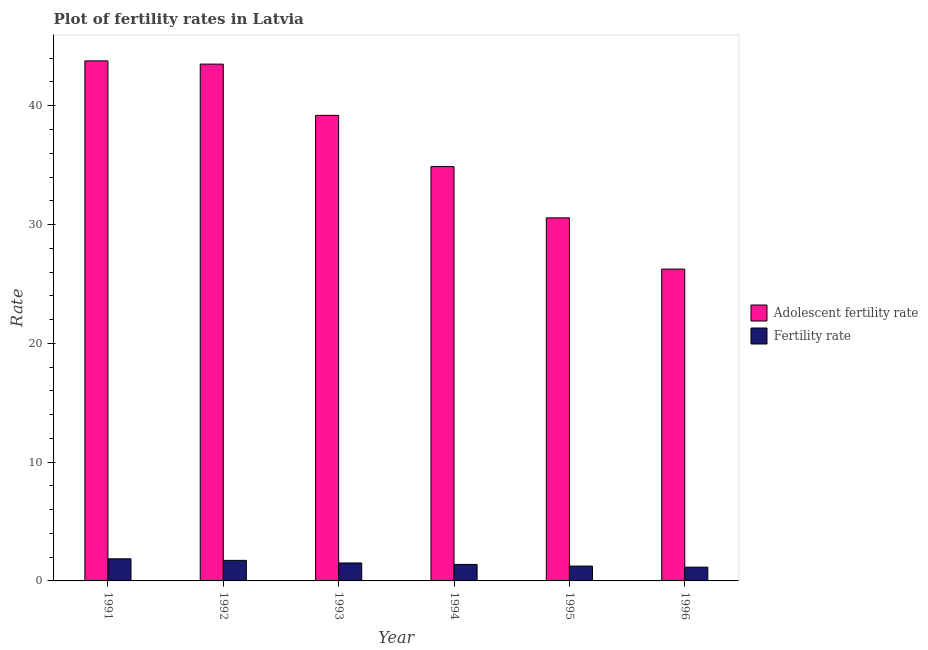How many different coloured bars are there?
Your response must be concise. 2. How many groups of bars are there?
Offer a terse response. 6. Are the number of bars on each tick of the X-axis equal?
Keep it short and to the point. Yes. How many bars are there on the 4th tick from the right?
Your response must be concise. 2. What is the label of the 3rd group of bars from the left?
Your response must be concise. 1993. In how many cases, is the number of bars for a given year not equal to the number of legend labels?
Provide a short and direct response. 0. What is the fertility rate in 1992?
Keep it short and to the point. 1.73. Across all years, what is the maximum adolescent fertility rate?
Give a very brief answer. 43.78. Across all years, what is the minimum adolescent fertility rate?
Offer a terse response. 26.25. In which year was the fertility rate minimum?
Keep it short and to the point. 1996. What is the total fertility rate in the graph?
Give a very brief answer. 8.9. What is the difference between the fertility rate in 1991 and that in 1994?
Keep it short and to the point. 0.47. What is the difference between the fertility rate in 1996 and the adolescent fertility rate in 1991?
Offer a very short reply. -0.7. What is the average adolescent fertility rate per year?
Keep it short and to the point. 36.36. In how many years, is the adolescent fertility rate greater than 14?
Ensure brevity in your answer.  6. What is the ratio of the adolescent fertility rate in 1991 to that in 1992?
Make the answer very short. 1.01. What is the difference between the highest and the second highest fertility rate?
Offer a very short reply. 0.13. What is the difference between the highest and the lowest adolescent fertility rate?
Offer a very short reply. 17.53. In how many years, is the fertility rate greater than the average fertility rate taken over all years?
Keep it short and to the point. 3. What does the 1st bar from the left in 1992 represents?
Offer a very short reply. Adolescent fertility rate. What does the 1st bar from the right in 1991 represents?
Keep it short and to the point. Fertility rate. How many years are there in the graph?
Give a very brief answer. 6. What is the difference between two consecutive major ticks on the Y-axis?
Your answer should be compact. 10. Are the values on the major ticks of Y-axis written in scientific E-notation?
Provide a succinct answer. No. Does the graph contain any zero values?
Provide a short and direct response. No. Where does the legend appear in the graph?
Offer a very short reply. Center right. How many legend labels are there?
Make the answer very short. 2. What is the title of the graph?
Make the answer very short. Plot of fertility rates in Latvia. What is the label or title of the X-axis?
Offer a terse response. Year. What is the label or title of the Y-axis?
Your answer should be very brief. Rate. What is the Rate in Adolescent fertility rate in 1991?
Give a very brief answer. 43.78. What is the Rate of Fertility rate in 1991?
Make the answer very short. 1.86. What is the Rate of Adolescent fertility rate in 1992?
Your answer should be compact. 43.51. What is the Rate in Fertility rate in 1992?
Your answer should be very brief. 1.73. What is the Rate of Adolescent fertility rate in 1993?
Offer a terse response. 39.19. What is the Rate of Fertility rate in 1993?
Provide a short and direct response. 1.51. What is the Rate in Adolescent fertility rate in 1994?
Provide a succinct answer. 34.88. What is the Rate in Fertility rate in 1994?
Provide a succinct answer. 1.39. What is the Rate in Adolescent fertility rate in 1995?
Offer a very short reply. 30.56. What is the Rate in Adolescent fertility rate in 1996?
Provide a succinct answer. 26.25. What is the Rate in Fertility rate in 1996?
Your response must be concise. 1.16. Across all years, what is the maximum Rate of Adolescent fertility rate?
Make the answer very short. 43.78. Across all years, what is the maximum Rate of Fertility rate?
Provide a succinct answer. 1.86. Across all years, what is the minimum Rate in Adolescent fertility rate?
Your answer should be compact. 26.25. Across all years, what is the minimum Rate of Fertility rate?
Provide a succinct answer. 1.16. What is the total Rate in Adolescent fertility rate in the graph?
Offer a terse response. 218.16. What is the total Rate in Fertility rate in the graph?
Give a very brief answer. 8.9. What is the difference between the Rate of Adolescent fertility rate in 1991 and that in 1992?
Ensure brevity in your answer.  0.27. What is the difference between the Rate of Fertility rate in 1991 and that in 1992?
Keep it short and to the point. 0.13. What is the difference between the Rate in Adolescent fertility rate in 1991 and that in 1993?
Provide a short and direct response. 4.59. What is the difference between the Rate in Adolescent fertility rate in 1991 and that in 1994?
Your answer should be compact. 8.9. What is the difference between the Rate in Fertility rate in 1991 and that in 1994?
Your response must be concise. 0.47. What is the difference between the Rate in Adolescent fertility rate in 1991 and that in 1995?
Your answer should be very brief. 13.21. What is the difference between the Rate of Fertility rate in 1991 and that in 1995?
Your answer should be compact. 0.61. What is the difference between the Rate of Adolescent fertility rate in 1991 and that in 1996?
Your response must be concise. 17.53. What is the difference between the Rate in Adolescent fertility rate in 1992 and that in 1993?
Provide a short and direct response. 4.31. What is the difference between the Rate in Fertility rate in 1992 and that in 1993?
Keep it short and to the point. 0.22. What is the difference between the Rate in Adolescent fertility rate in 1992 and that in 1994?
Give a very brief answer. 8.63. What is the difference between the Rate in Fertility rate in 1992 and that in 1994?
Make the answer very short. 0.34. What is the difference between the Rate in Adolescent fertility rate in 1992 and that in 1995?
Offer a very short reply. 12.94. What is the difference between the Rate in Fertility rate in 1992 and that in 1995?
Make the answer very short. 0.48. What is the difference between the Rate in Adolescent fertility rate in 1992 and that in 1996?
Your response must be concise. 17.26. What is the difference between the Rate of Fertility rate in 1992 and that in 1996?
Offer a terse response. 0.57. What is the difference between the Rate of Adolescent fertility rate in 1993 and that in 1994?
Make the answer very short. 4.31. What is the difference between the Rate of Fertility rate in 1993 and that in 1994?
Offer a terse response. 0.12. What is the difference between the Rate in Adolescent fertility rate in 1993 and that in 1995?
Offer a terse response. 8.63. What is the difference between the Rate of Fertility rate in 1993 and that in 1995?
Ensure brevity in your answer.  0.26. What is the difference between the Rate in Adolescent fertility rate in 1993 and that in 1996?
Offer a very short reply. 12.94. What is the difference between the Rate of Fertility rate in 1993 and that in 1996?
Keep it short and to the point. 0.35. What is the difference between the Rate in Adolescent fertility rate in 1994 and that in 1995?
Give a very brief answer. 4.31. What is the difference between the Rate of Fertility rate in 1994 and that in 1995?
Offer a terse response. 0.14. What is the difference between the Rate of Adolescent fertility rate in 1994 and that in 1996?
Give a very brief answer. 8.63. What is the difference between the Rate in Fertility rate in 1994 and that in 1996?
Ensure brevity in your answer.  0.23. What is the difference between the Rate of Adolescent fertility rate in 1995 and that in 1996?
Offer a terse response. 4.31. What is the difference between the Rate in Fertility rate in 1995 and that in 1996?
Ensure brevity in your answer.  0.09. What is the difference between the Rate in Adolescent fertility rate in 1991 and the Rate in Fertility rate in 1992?
Provide a short and direct response. 42.05. What is the difference between the Rate in Adolescent fertility rate in 1991 and the Rate in Fertility rate in 1993?
Your answer should be very brief. 42.27. What is the difference between the Rate in Adolescent fertility rate in 1991 and the Rate in Fertility rate in 1994?
Offer a terse response. 42.39. What is the difference between the Rate in Adolescent fertility rate in 1991 and the Rate in Fertility rate in 1995?
Provide a short and direct response. 42.53. What is the difference between the Rate of Adolescent fertility rate in 1991 and the Rate of Fertility rate in 1996?
Your response must be concise. 42.62. What is the difference between the Rate of Adolescent fertility rate in 1992 and the Rate of Fertility rate in 1993?
Make the answer very short. 41.99. What is the difference between the Rate of Adolescent fertility rate in 1992 and the Rate of Fertility rate in 1994?
Offer a terse response. 42.12. What is the difference between the Rate in Adolescent fertility rate in 1992 and the Rate in Fertility rate in 1995?
Make the answer very short. 42.26. What is the difference between the Rate in Adolescent fertility rate in 1992 and the Rate in Fertility rate in 1996?
Provide a succinct answer. 42.34. What is the difference between the Rate of Adolescent fertility rate in 1993 and the Rate of Fertility rate in 1994?
Offer a very short reply. 37.8. What is the difference between the Rate of Adolescent fertility rate in 1993 and the Rate of Fertility rate in 1995?
Make the answer very short. 37.94. What is the difference between the Rate in Adolescent fertility rate in 1993 and the Rate in Fertility rate in 1996?
Your response must be concise. 38.03. What is the difference between the Rate of Adolescent fertility rate in 1994 and the Rate of Fertility rate in 1995?
Provide a succinct answer. 33.63. What is the difference between the Rate of Adolescent fertility rate in 1994 and the Rate of Fertility rate in 1996?
Keep it short and to the point. 33.72. What is the difference between the Rate of Adolescent fertility rate in 1995 and the Rate of Fertility rate in 1996?
Provide a short and direct response. 29.4. What is the average Rate in Adolescent fertility rate per year?
Give a very brief answer. 36.36. What is the average Rate of Fertility rate per year?
Provide a succinct answer. 1.48. In the year 1991, what is the difference between the Rate in Adolescent fertility rate and Rate in Fertility rate?
Your answer should be compact. 41.92. In the year 1992, what is the difference between the Rate in Adolescent fertility rate and Rate in Fertility rate?
Make the answer very short. 41.77. In the year 1993, what is the difference between the Rate in Adolescent fertility rate and Rate in Fertility rate?
Give a very brief answer. 37.68. In the year 1994, what is the difference between the Rate of Adolescent fertility rate and Rate of Fertility rate?
Give a very brief answer. 33.49. In the year 1995, what is the difference between the Rate of Adolescent fertility rate and Rate of Fertility rate?
Your answer should be compact. 29.31. In the year 1996, what is the difference between the Rate in Adolescent fertility rate and Rate in Fertility rate?
Your answer should be compact. 25.09. What is the ratio of the Rate in Adolescent fertility rate in 1991 to that in 1992?
Make the answer very short. 1.01. What is the ratio of the Rate in Fertility rate in 1991 to that in 1992?
Offer a terse response. 1.08. What is the ratio of the Rate of Adolescent fertility rate in 1991 to that in 1993?
Your response must be concise. 1.12. What is the ratio of the Rate in Fertility rate in 1991 to that in 1993?
Keep it short and to the point. 1.23. What is the ratio of the Rate of Adolescent fertility rate in 1991 to that in 1994?
Keep it short and to the point. 1.26. What is the ratio of the Rate of Fertility rate in 1991 to that in 1994?
Your answer should be compact. 1.34. What is the ratio of the Rate in Adolescent fertility rate in 1991 to that in 1995?
Provide a short and direct response. 1.43. What is the ratio of the Rate of Fertility rate in 1991 to that in 1995?
Offer a very short reply. 1.49. What is the ratio of the Rate in Adolescent fertility rate in 1991 to that in 1996?
Offer a terse response. 1.67. What is the ratio of the Rate in Fertility rate in 1991 to that in 1996?
Your answer should be very brief. 1.6. What is the ratio of the Rate in Adolescent fertility rate in 1992 to that in 1993?
Your response must be concise. 1.11. What is the ratio of the Rate of Fertility rate in 1992 to that in 1993?
Your answer should be very brief. 1.15. What is the ratio of the Rate of Adolescent fertility rate in 1992 to that in 1994?
Offer a very short reply. 1.25. What is the ratio of the Rate in Fertility rate in 1992 to that in 1994?
Your answer should be very brief. 1.24. What is the ratio of the Rate in Adolescent fertility rate in 1992 to that in 1995?
Ensure brevity in your answer.  1.42. What is the ratio of the Rate of Fertility rate in 1992 to that in 1995?
Ensure brevity in your answer.  1.38. What is the ratio of the Rate in Adolescent fertility rate in 1992 to that in 1996?
Your response must be concise. 1.66. What is the ratio of the Rate of Fertility rate in 1992 to that in 1996?
Give a very brief answer. 1.49. What is the ratio of the Rate of Adolescent fertility rate in 1993 to that in 1994?
Provide a succinct answer. 1.12. What is the ratio of the Rate of Fertility rate in 1993 to that in 1994?
Ensure brevity in your answer.  1.09. What is the ratio of the Rate in Adolescent fertility rate in 1993 to that in 1995?
Your response must be concise. 1.28. What is the ratio of the Rate in Fertility rate in 1993 to that in 1995?
Provide a succinct answer. 1.21. What is the ratio of the Rate in Adolescent fertility rate in 1993 to that in 1996?
Make the answer very short. 1.49. What is the ratio of the Rate in Fertility rate in 1993 to that in 1996?
Give a very brief answer. 1.3. What is the ratio of the Rate in Adolescent fertility rate in 1994 to that in 1995?
Offer a very short reply. 1.14. What is the ratio of the Rate in Fertility rate in 1994 to that in 1995?
Your answer should be very brief. 1.11. What is the ratio of the Rate in Adolescent fertility rate in 1994 to that in 1996?
Your response must be concise. 1.33. What is the ratio of the Rate of Fertility rate in 1994 to that in 1996?
Your response must be concise. 1.2. What is the ratio of the Rate of Adolescent fertility rate in 1995 to that in 1996?
Your answer should be compact. 1.16. What is the ratio of the Rate of Fertility rate in 1995 to that in 1996?
Keep it short and to the point. 1.08. What is the difference between the highest and the second highest Rate of Adolescent fertility rate?
Make the answer very short. 0.27. What is the difference between the highest and the second highest Rate of Fertility rate?
Your answer should be very brief. 0.13. What is the difference between the highest and the lowest Rate in Adolescent fertility rate?
Your answer should be very brief. 17.53. 